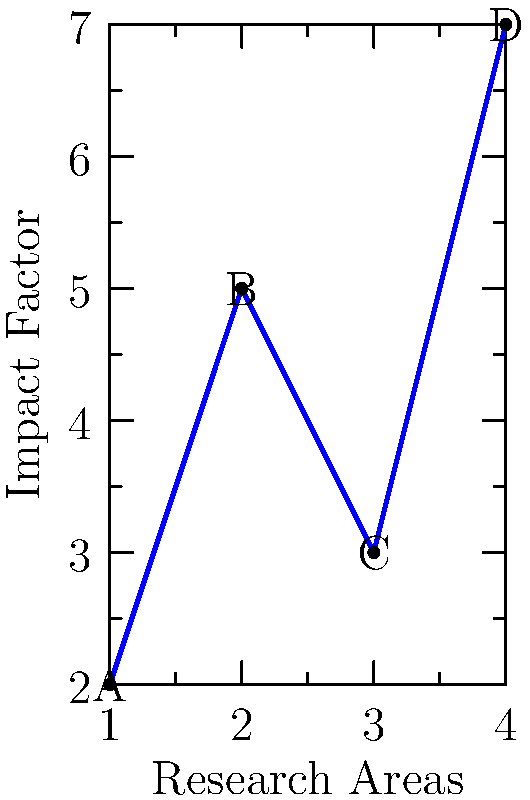As a graduate student, you're analyzing the impact of various research areas in your field. The graph shows the impact factors of four different research areas (A, B, C, and D). If you represent each research area as a vector from the origin to its corresponding point on the graph, which research area would have the largest vector magnitude, indicating the highest overall impact? To determine which research area has the largest vector magnitude, we need to calculate the magnitude of each vector and compare them. The magnitude of a 2D vector is given by the formula:

$$\text{magnitude} = \sqrt{x^2 + y^2}$$

Let's calculate the magnitude for each research area:

1. Area A: $(1, 2)$
   $$\text{magnitude}_A = \sqrt{1^2 + 2^2} = \sqrt{5} \approx 2.24$$

2. Area B: $(2, 5)$
   $$\text{magnitude}_B = \sqrt{2^2 + 5^2} = \sqrt{29} \approx 5.39$$

3. Area C: $(3, 3)$
   $$\text{magnitude}_C = \sqrt{3^2 + 3^2} = \sqrt{18} \approx 4.24$$

4. Area D: $(4, 7)$
   $$\text{magnitude}_D = \sqrt{4^2 + 7^2} = \sqrt{65} \approx 8.06$$

Comparing these magnitudes, we can see that Area D has the largest vector magnitude.
Answer: Area D 